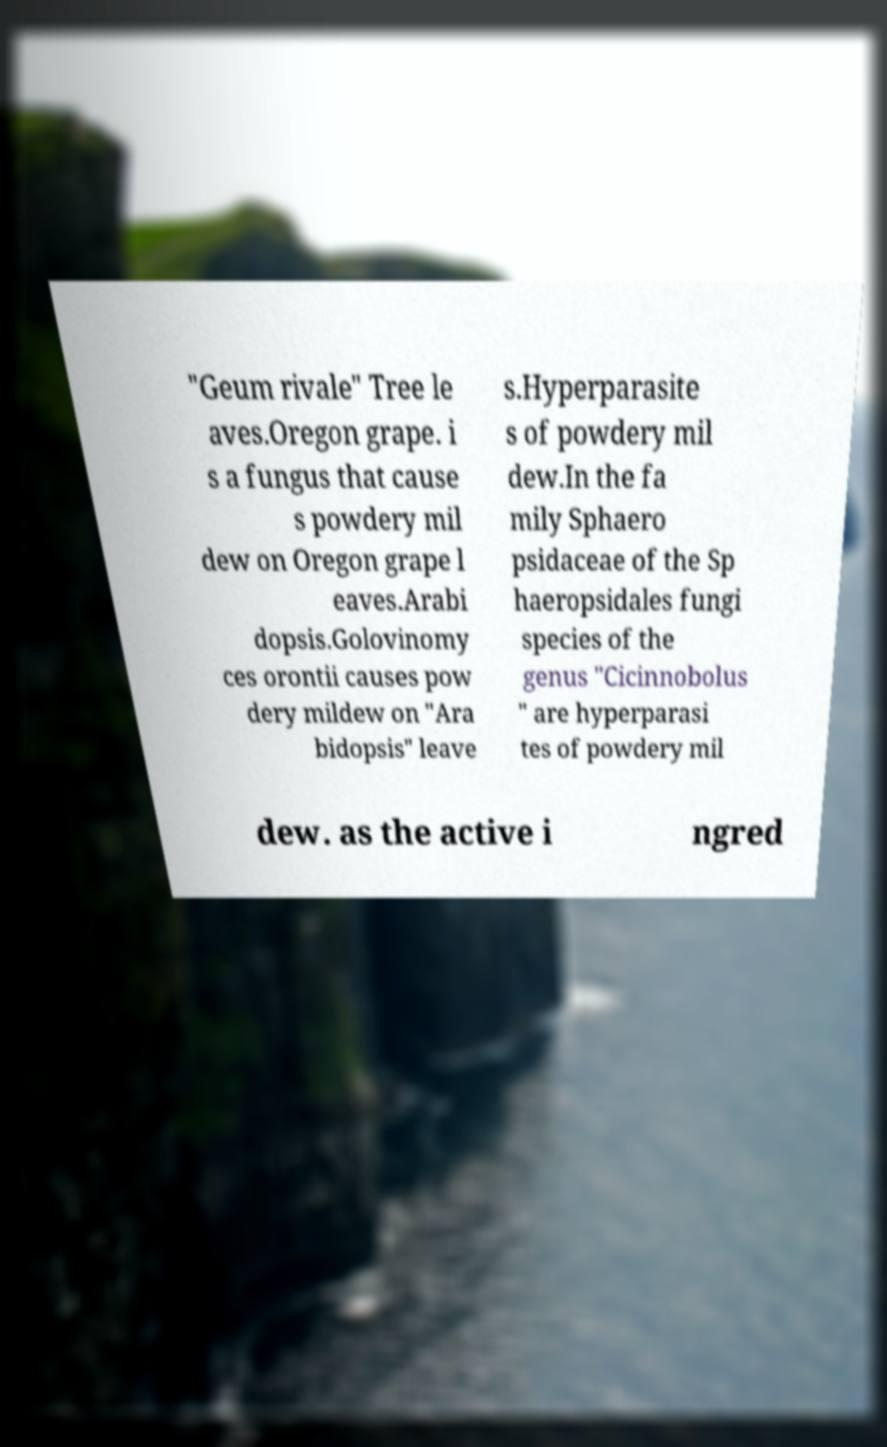Could you extract and type out the text from this image? "Geum rivale" Tree le aves.Oregon grape. i s a fungus that cause s powdery mil dew on Oregon grape l eaves.Arabi dopsis.Golovinomy ces orontii causes pow dery mildew on "Ara bidopsis" leave s.Hyperparasite s of powdery mil dew.In the fa mily Sphaero psidaceae of the Sp haeropsidales fungi species of the genus "Cicinnobolus " are hyperparasi tes of powdery mil dew. as the active i ngred 